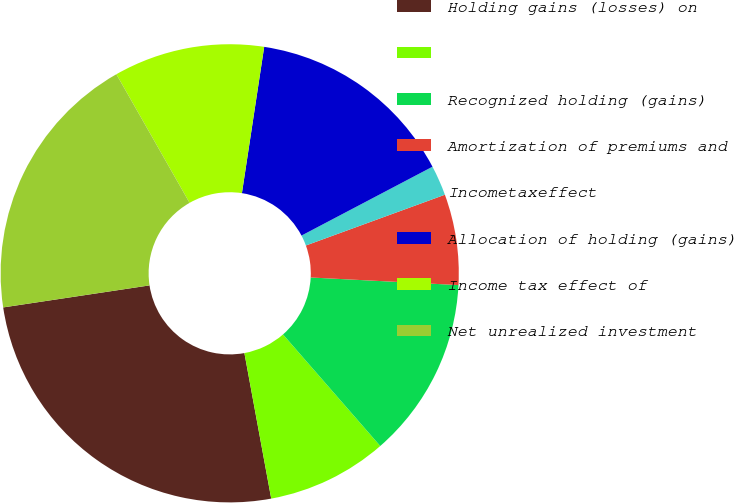Convert chart to OTSL. <chart><loc_0><loc_0><loc_500><loc_500><pie_chart><fcel>Holding gains (losses) on<fcel>Unnamed: 1<fcel>Recognized holding (gains)<fcel>Amortization of premiums and<fcel>Incometaxeffect<fcel>Allocation of holding (gains)<fcel>Income tax effect of<fcel>Net unrealized investment<nl><fcel>25.52%<fcel>8.51%<fcel>12.77%<fcel>6.39%<fcel>2.13%<fcel>14.89%<fcel>10.64%<fcel>19.14%<nl></chart> 